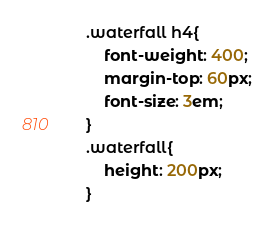<code> <loc_0><loc_0><loc_500><loc_500><_CSS_>.waterfall h4{
    font-weight: 400;
    margin-top: 60px;
    font-size: 3em;
}
.waterfall{
    height: 200px;
}</code> 